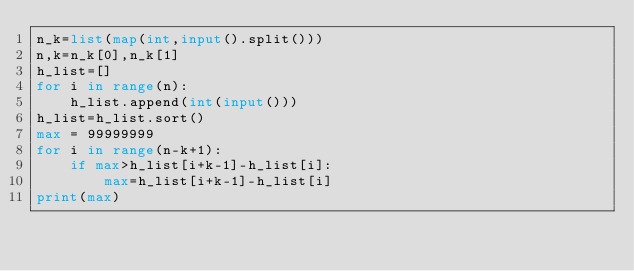<code> <loc_0><loc_0><loc_500><loc_500><_Python_>n_k=list(map(int,input().split()))
n,k=n_k[0],n_k[1]
h_list=[]
for i in range(n):
    h_list.append(int(input()))
h_list=h_list.sort()
max = 99999999
for i in range(n-k+1):
    if max>h_list[i+k-1]-h_list[i]:
        max=h_list[i+k-1]-h_list[i]
print(max)
    
</code> 